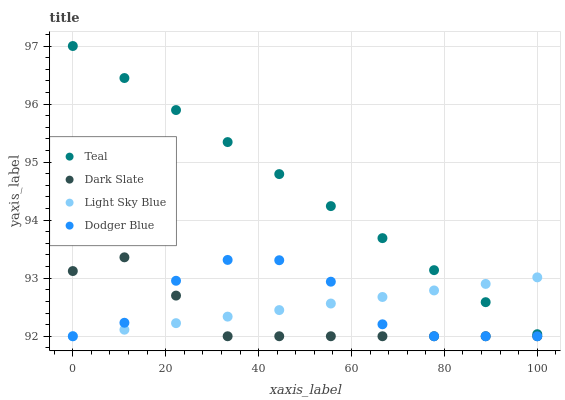Does Dark Slate have the minimum area under the curve?
Answer yes or no. Yes. Does Teal have the maximum area under the curve?
Answer yes or no. Yes. Does Light Sky Blue have the minimum area under the curve?
Answer yes or no. No. Does Light Sky Blue have the maximum area under the curve?
Answer yes or no. No. Is Light Sky Blue the smoothest?
Answer yes or no. Yes. Is Dodger Blue the roughest?
Answer yes or no. Yes. Is Dodger Blue the smoothest?
Answer yes or no. No. Is Light Sky Blue the roughest?
Answer yes or no. No. Does Dark Slate have the lowest value?
Answer yes or no. Yes. Does Teal have the lowest value?
Answer yes or no. No. Does Teal have the highest value?
Answer yes or no. Yes. Does Dodger Blue have the highest value?
Answer yes or no. No. Is Dark Slate less than Teal?
Answer yes or no. Yes. Is Teal greater than Dark Slate?
Answer yes or no. Yes. Does Light Sky Blue intersect Dodger Blue?
Answer yes or no. Yes. Is Light Sky Blue less than Dodger Blue?
Answer yes or no. No. Is Light Sky Blue greater than Dodger Blue?
Answer yes or no. No. Does Dark Slate intersect Teal?
Answer yes or no. No. 